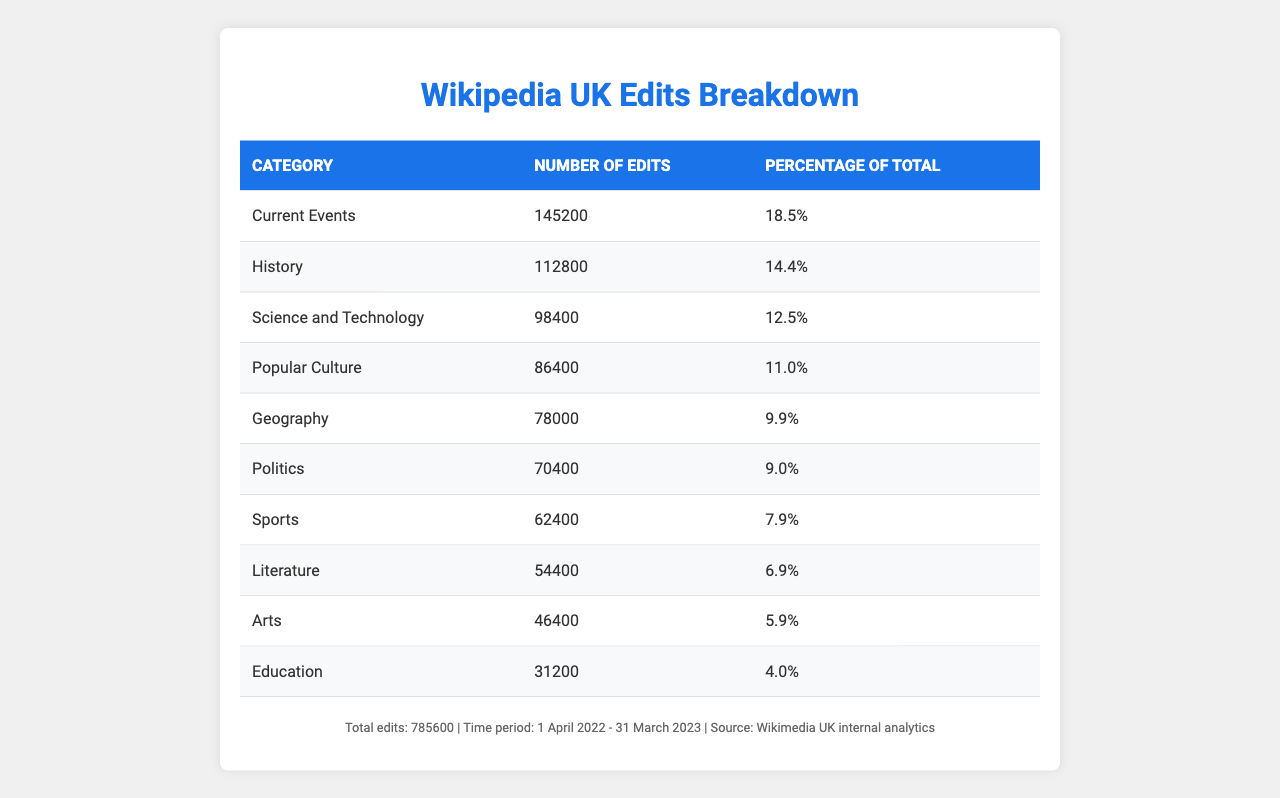What is the total number of edits by UK contributors? The table states the total number of edits at the bottom, which is 785600.
Answer: 785600 Which category received the most edits? Looking at the "Number of Edits" column, "Current Events" has the highest number of edits with 145200.
Answer: Current Events What percentage of edits were made in the category "Sports"? The "Percentage of Total" column shows that Sports had 7.9% of the edits.
Answer: 7.9% How many edits were made in the "Geography" category? The table lists "Geography" with a corresponding number of edits as 78000.
Answer: 78000 What is the difference in the number of edits between "History" and "Science and Technology"? "History" has 112800 edits and "Science and Technology" has 98400 edits; the difference is 112800 - 98400 = 14400.
Answer: 14400 What is the average number of edits for the top three categories? The top three categories are Current Events (145200), History (112800), and Science and Technology (98400). The sum is 145200 + 112800 + 98400 = 356400, and dividing by 3 gives an average of 118800.
Answer: 118800 Is the number of edits in "Education" greater than 30000? The table shows that "Education" has 31200 edits, which is greater than 30000.
Answer: Yes What percentage of the total edits are made in the "Arts" category? The table indicates that "Arts" accounts for 5.9% of the total edits.
Answer: 5.9% How many more edits were made in the "Current Events" category compared to the "Literature" category? "Current Events" has 145200 edits and "Literature" has 54400; the difference is 145200 - 54400 = 90800.
Answer: 90800 Which category had the least number of edits, and how many were there? By examining the "Number of Edits" column, "Education" has the least number of edits with 31200.
Answer: Education, 31200 